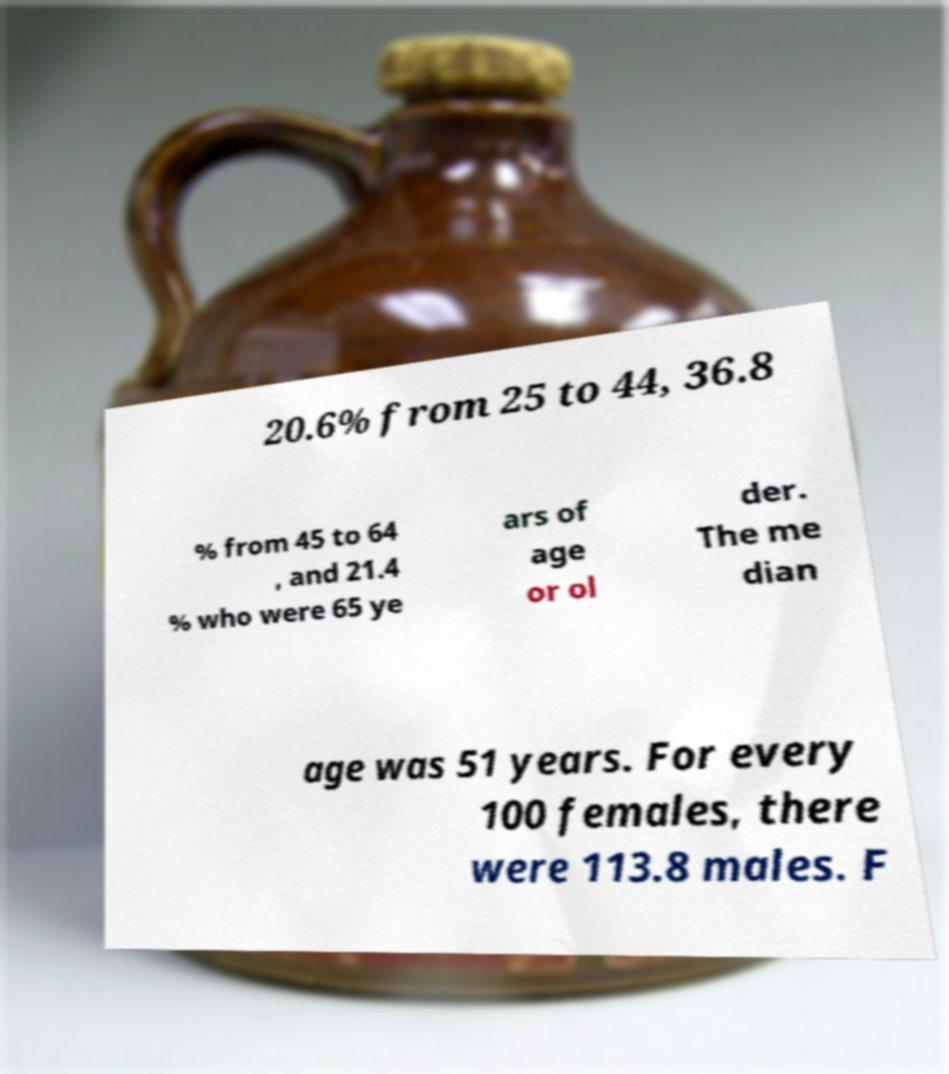I need the written content from this picture converted into text. Can you do that? 20.6% from 25 to 44, 36.8 % from 45 to 64 , and 21.4 % who were 65 ye ars of age or ol der. The me dian age was 51 years. For every 100 females, there were 113.8 males. F 